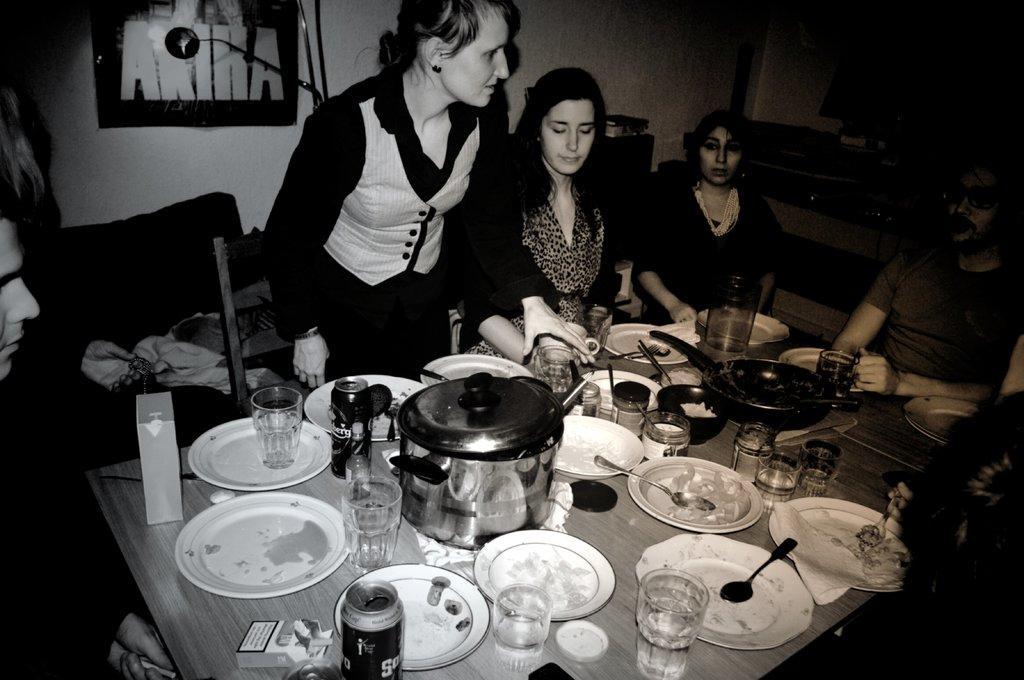Please provide a concise description of this image. In this image I can see five persons are sitting on the chairs in front of a table on which I can see plates, bowls, vessels, glasses and food items and one person is standing on the floor. In the background I can see a wall, wall painting and so on. This image is taken may be in a hall. 